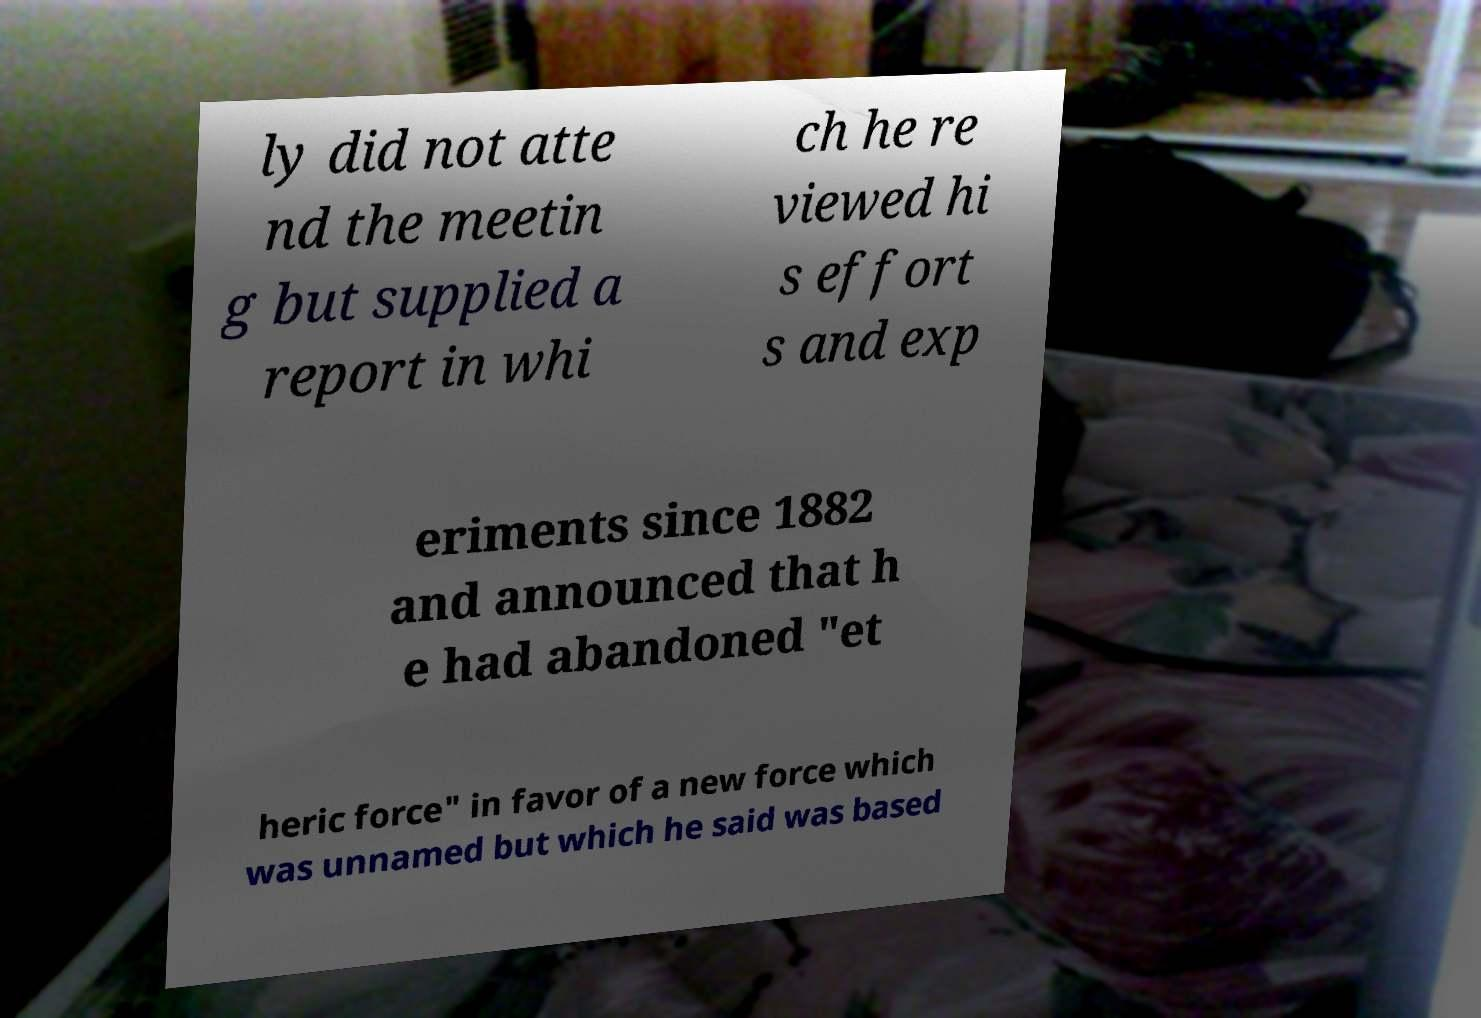I need the written content from this picture converted into text. Can you do that? ly did not atte nd the meetin g but supplied a report in whi ch he re viewed hi s effort s and exp eriments since 1882 and announced that h e had abandoned "et heric force" in favor of a new force which was unnamed but which he said was based 